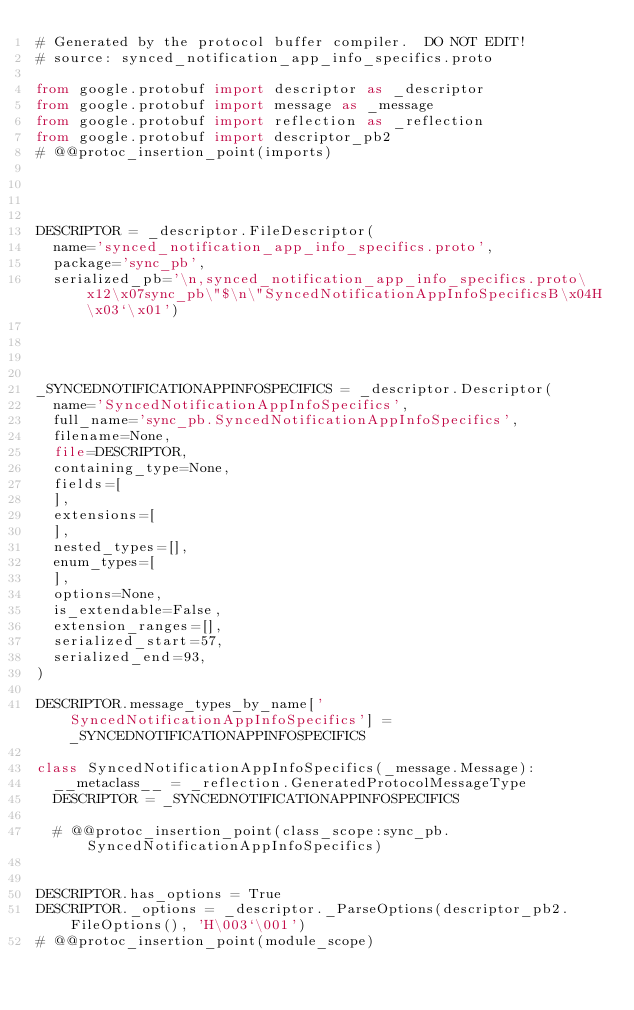<code> <loc_0><loc_0><loc_500><loc_500><_Python_># Generated by the protocol buffer compiler.  DO NOT EDIT!
# source: synced_notification_app_info_specifics.proto

from google.protobuf import descriptor as _descriptor
from google.protobuf import message as _message
from google.protobuf import reflection as _reflection
from google.protobuf import descriptor_pb2
# @@protoc_insertion_point(imports)




DESCRIPTOR = _descriptor.FileDescriptor(
  name='synced_notification_app_info_specifics.proto',
  package='sync_pb',
  serialized_pb='\n,synced_notification_app_info_specifics.proto\x12\x07sync_pb\"$\n\"SyncedNotificationAppInfoSpecificsB\x04H\x03`\x01')




_SYNCEDNOTIFICATIONAPPINFOSPECIFICS = _descriptor.Descriptor(
  name='SyncedNotificationAppInfoSpecifics',
  full_name='sync_pb.SyncedNotificationAppInfoSpecifics',
  filename=None,
  file=DESCRIPTOR,
  containing_type=None,
  fields=[
  ],
  extensions=[
  ],
  nested_types=[],
  enum_types=[
  ],
  options=None,
  is_extendable=False,
  extension_ranges=[],
  serialized_start=57,
  serialized_end=93,
)

DESCRIPTOR.message_types_by_name['SyncedNotificationAppInfoSpecifics'] = _SYNCEDNOTIFICATIONAPPINFOSPECIFICS

class SyncedNotificationAppInfoSpecifics(_message.Message):
  __metaclass__ = _reflection.GeneratedProtocolMessageType
  DESCRIPTOR = _SYNCEDNOTIFICATIONAPPINFOSPECIFICS

  # @@protoc_insertion_point(class_scope:sync_pb.SyncedNotificationAppInfoSpecifics)


DESCRIPTOR.has_options = True
DESCRIPTOR._options = _descriptor._ParseOptions(descriptor_pb2.FileOptions(), 'H\003`\001')
# @@protoc_insertion_point(module_scope)
</code> 